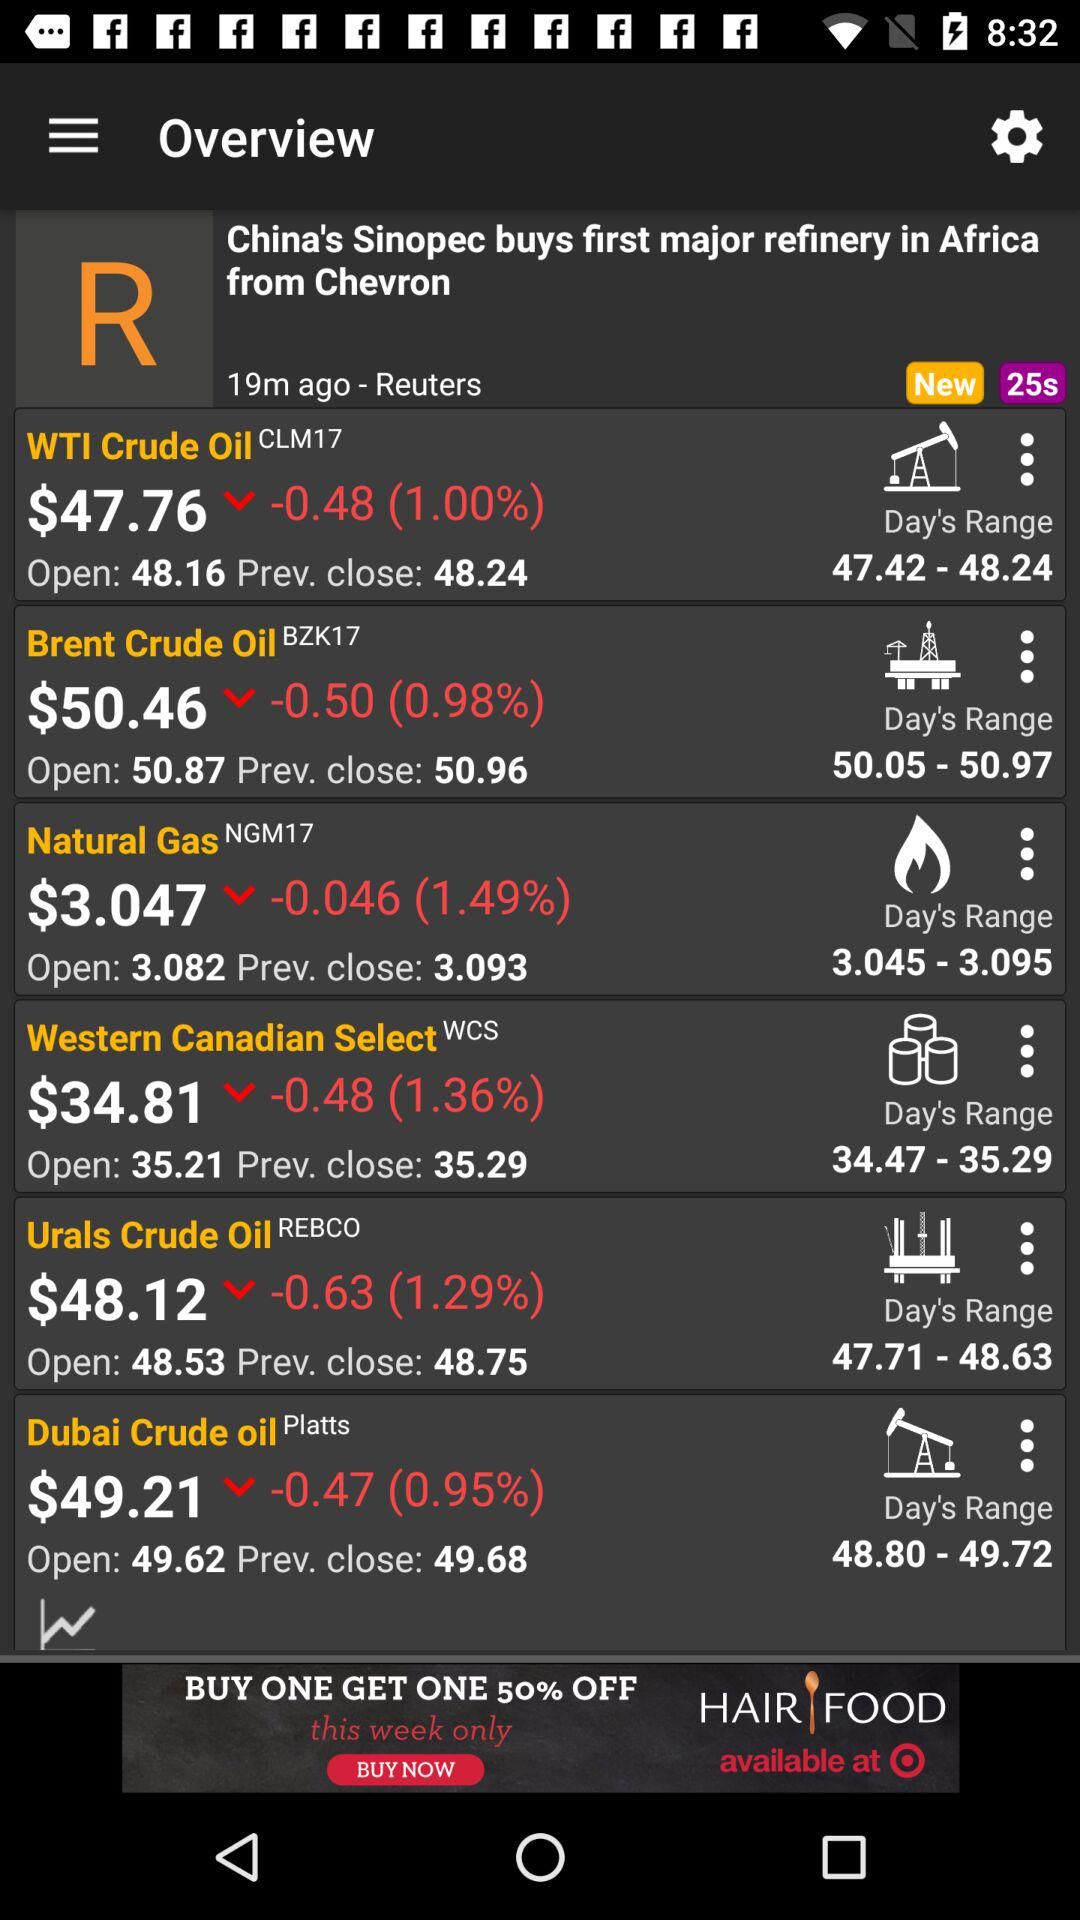How many minutes ago was the post shared? The post was shared 19 minutes ago. 